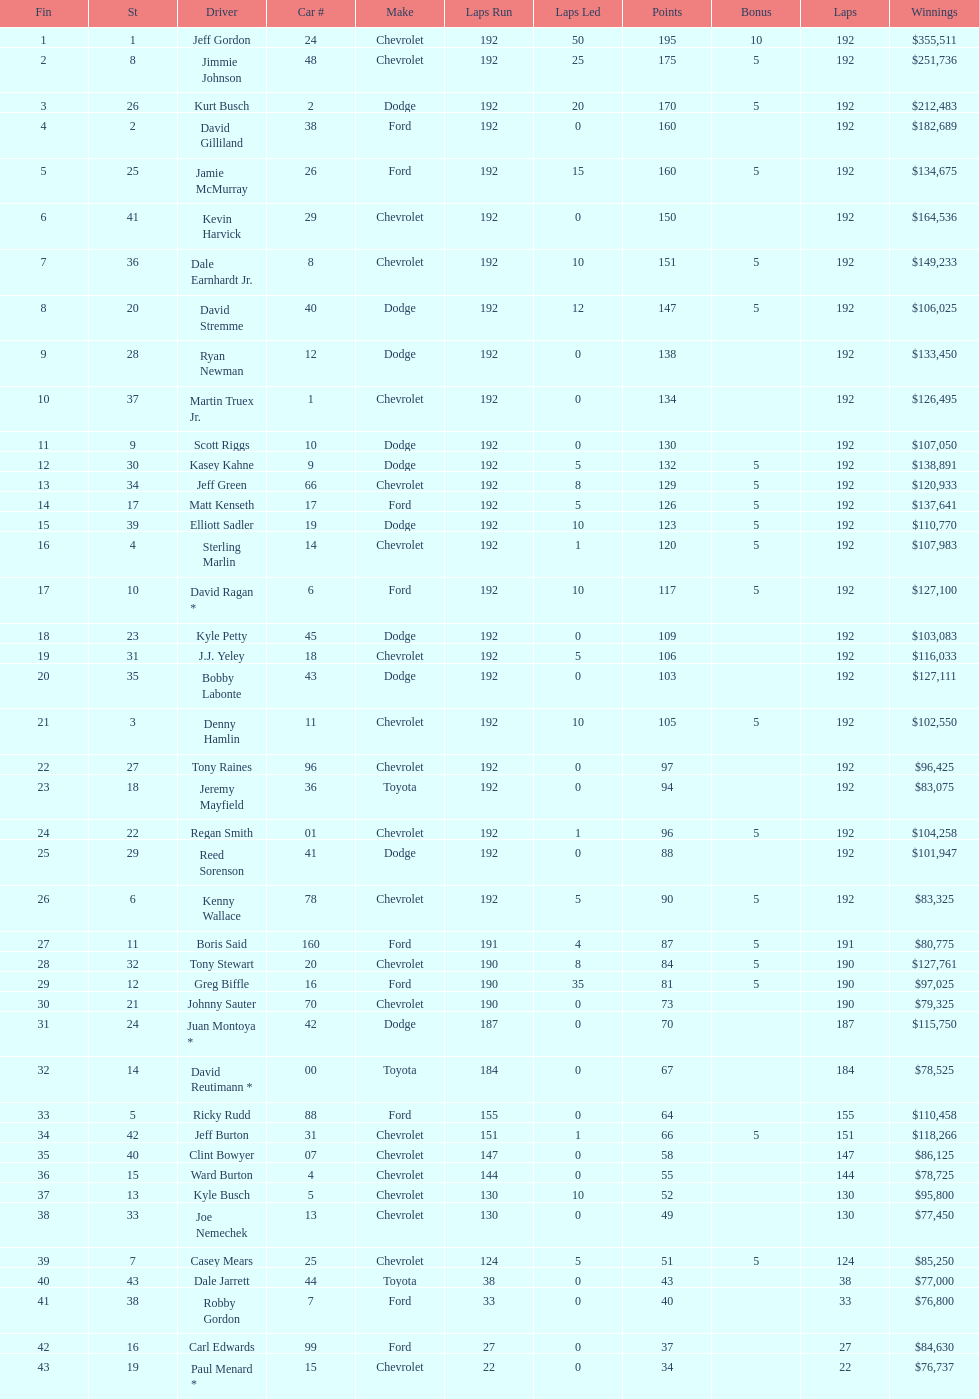Which make had the most consecutive finishes at the aarons 499? Chevrolet. 